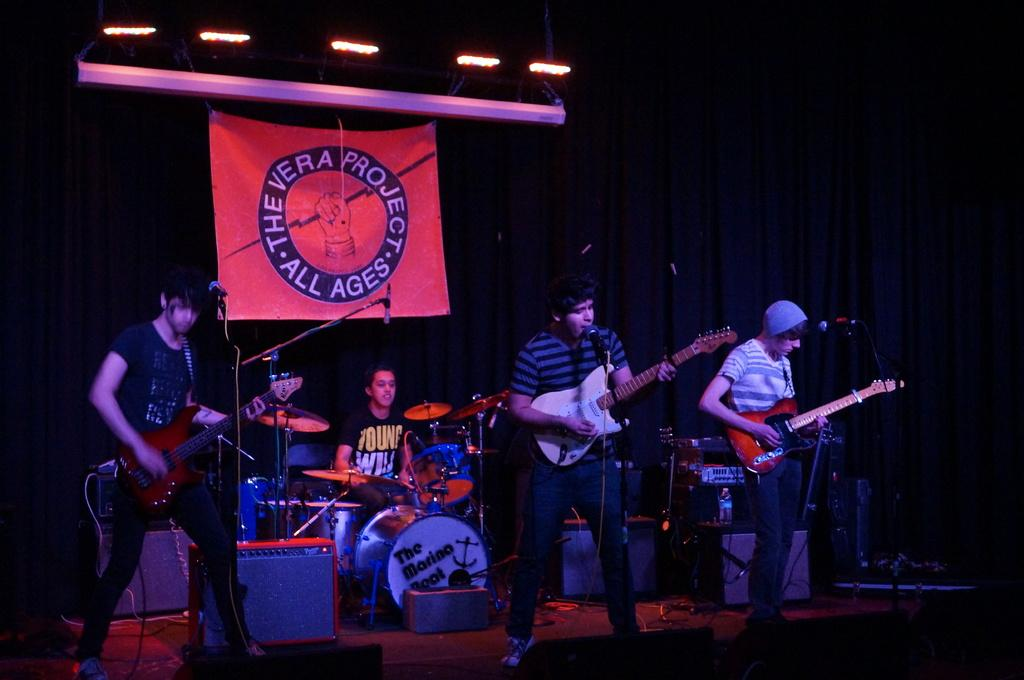How many people are in the image? There is a group of persons in the image. What are the persons in the image doing? The persons are playing musical instruments. Can you describe any additional elements in the image? There is a banner at the top of the image. What type of cracker is being used as a drumstick in the image? There is no cracker or drumstick present in the image; the persons are playing musical instruments without any visible crackers. 